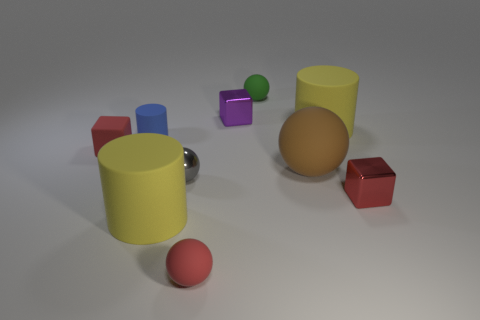What number of things are either matte cylinders in front of the red metallic thing or shiny objects?
Your answer should be compact. 4. Is the number of large rubber balls on the left side of the gray metallic sphere the same as the number of large spheres?
Provide a short and direct response. No. Does the tiny rubber cylinder have the same color as the tiny metallic sphere?
Your answer should be compact. No. The matte object that is on the right side of the small metal ball and in front of the small gray metallic sphere is what color?
Keep it short and to the point. Red. What number of blocks are either red metal things or green objects?
Your response must be concise. 1. Is the number of metal cubes that are behind the blue object less than the number of red blocks?
Make the answer very short. Yes. What is the shape of the gray object that is made of the same material as the small purple block?
Ensure brevity in your answer.  Sphere. What number of small metallic things have the same color as the small metallic ball?
Ensure brevity in your answer.  0. How many things are either big rubber balls or tiny red matte things?
Make the answer very short. 3. There is a yellow thing behind the yellow rubber object on the left side of the brown rubber ball; what is its material?
Ensure brevity in your answer.  Rubber. 